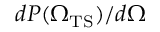<formula> <loc_0><loc_0><loc_500><loc_500>d P ( { \Omega _ { T S } ) } / d \Omega</formula> 